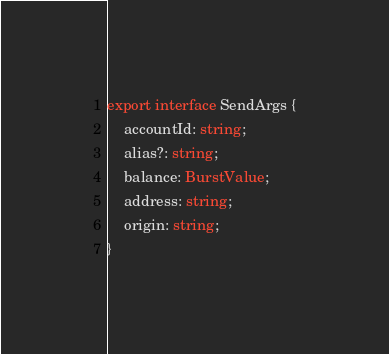<code> <loc_0><loc_0><loc_500><loc_500><_TypeScript_>
export interface SendArgs {
    accountId: string;
    alias?: string;
    balance: BurstValue;
    address: string;
    origin: string;
}
</code> 